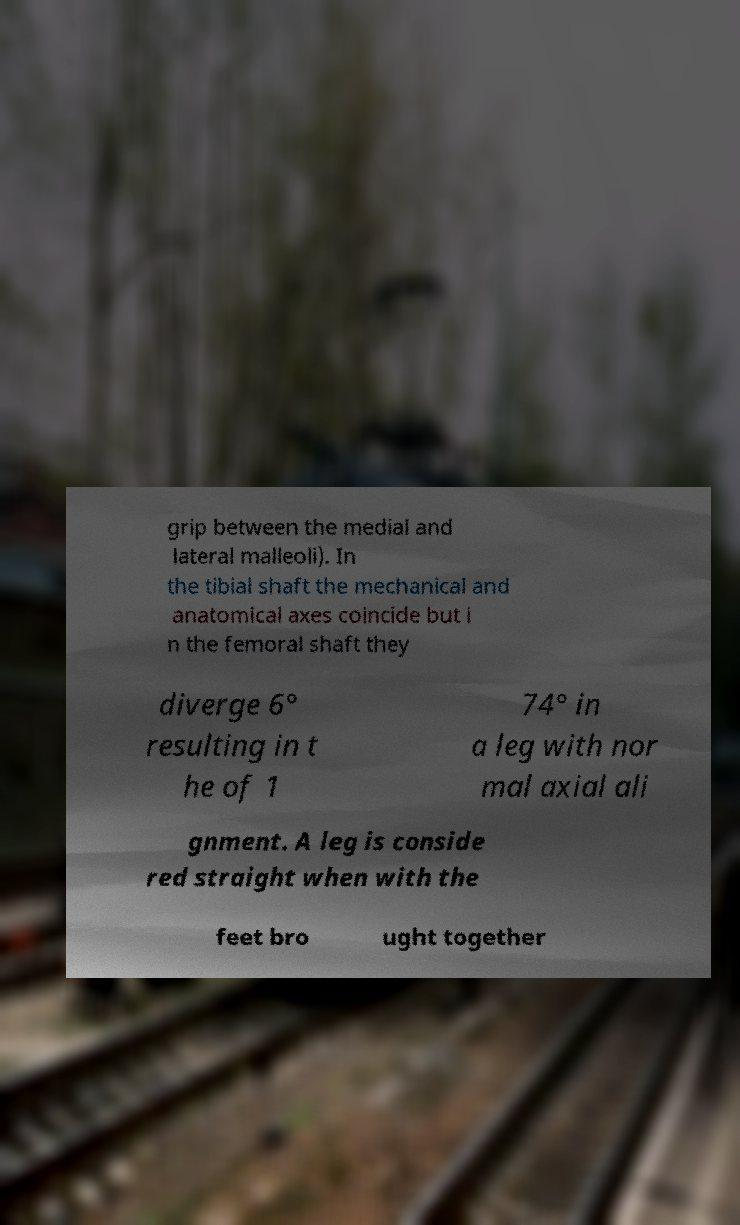Can you accurately transcribe the text from the provided image for me? grip between the medial and lateral malleoli). In the tibial shaft the mechanical and anatomical axes coincide but i n the femoral shaft they diverge 6° resulting in t he of 1 74° in a leg with nor mal axial ali gnment. A leg is conside red straight when with the feet bro ught together 